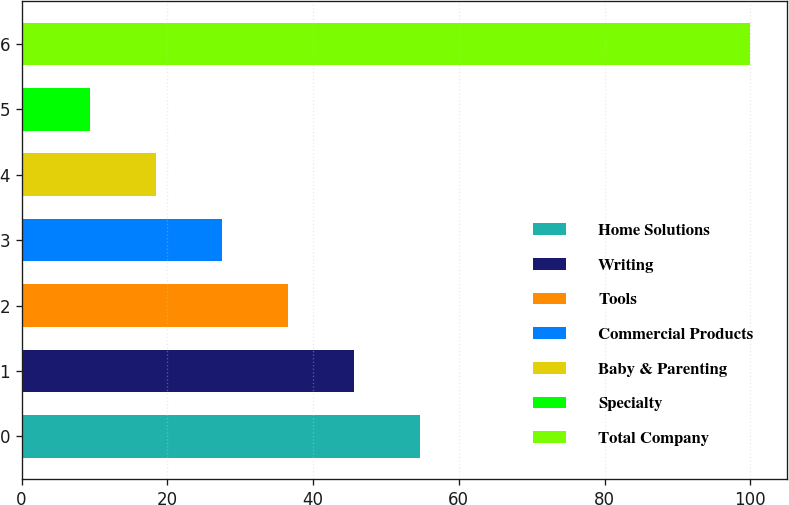<chart> <loc_0><loc_0><loc_500><loc_500><bar_chart><fcel>Home Solutions<fcel>Writing<fcel>Tools<fcel>Commercial Products<fcel>Baby & Parenting<fcel>Specialty<fcel>Total Company<nl><fcel>54.7<fcel>45.64<fcel>36.58<fcel>27.52<fcel>18.46<fcel>9.4<fcel>100<nl></chart> 